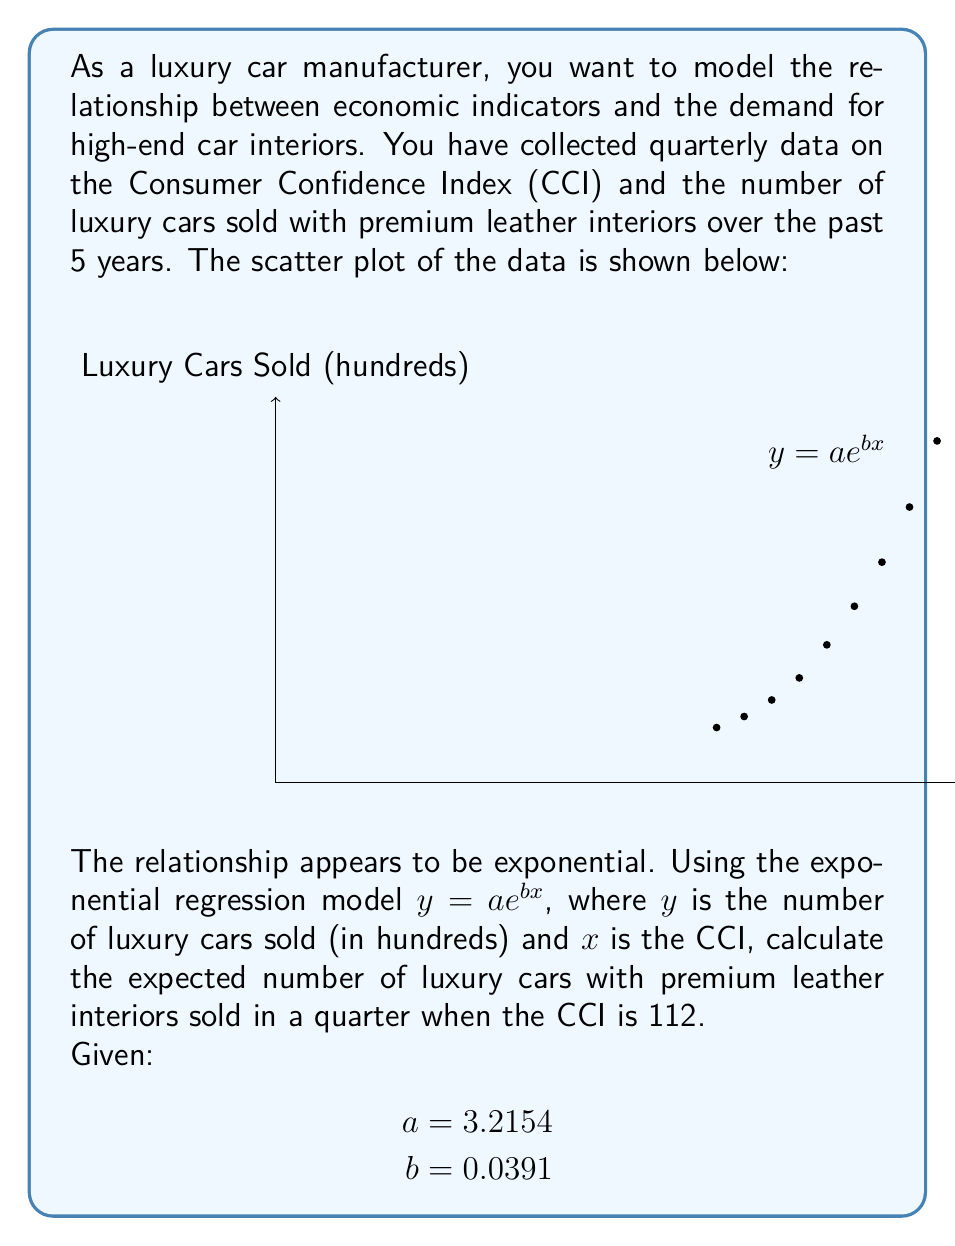Teach me how to tackle this problem. To solve this problem, we'll follow these steps:

1) We're given the exponential regression model:
   $y = ae^{bx}$

2) We're also given the values of the constants:
   $a = 3.2154$
   $b = 0.0391$

3) We need to find $y$ when $x = 112$ (CCI = 112)

4) Let's substitute these values into our equation:
   $y = 3.2154 \cdot e^{0.0391 \cdot 112}$

5) Now, let's calculate:
   $y = 3.2154 \cdot e^{4.3792}$
   $y = 3.2154 \cdot 79.8106$
   $y = 256.6254$

6) Remember, $y$ is in hundreds of cars. So we need to multiply by 100:
   $256.6254 \cdot 100 = 25,662.54$

7) Rounding to the nearest whole number (as we can't sell partial cars):
   $25,663$ luxury cars
Answer: 25,663 luxury cars 